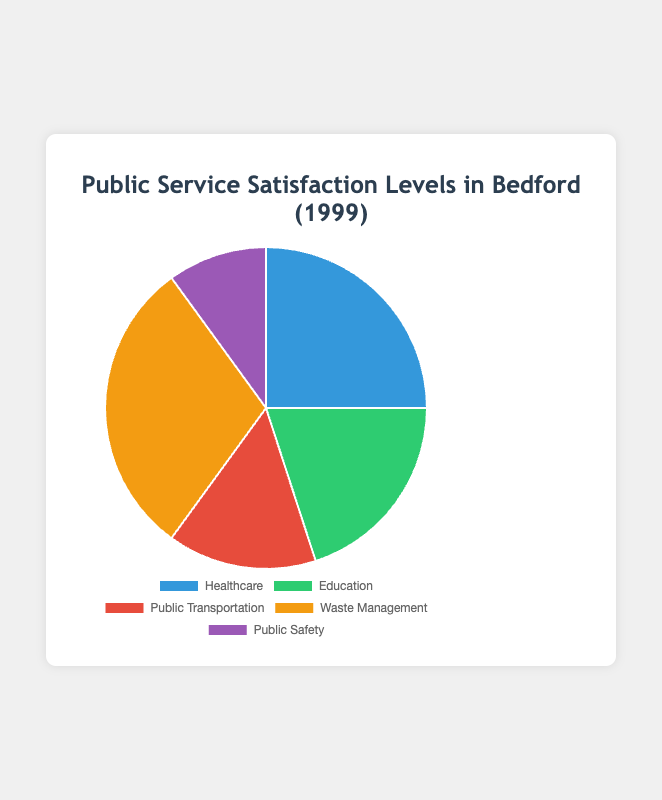Which public service category has the highest satisfaction level? The pie chart shows the percentage distribution of satisfaction levels. The segment with the highest value represents the category with the highest satisfaction level.
Answer: Waste Management Which category accounts for the smallest portion of satisfaction? By examining the pie chart, the smallest segment represents the category with the lowest satisfaction percentage.
Answer: Public Safety What is the total satisfaction percentage for Healthcare and Education combined? Add the satisfaction percentages of Healthcare and Education: 25% (Healthcare) + 20% (Education) = 45%.
Answer: 45% How much lower is the satisfaction level for Public Safety compared to Waste Management? Subtract the satisfaction percentage of Public Safety (10%) from Waste Management (30%): 30% - 10% = 20%.
Answer: 20% If you combined the satisfaction levels of Public Transportation and Public Safety, would it be higher, lower, or equal to Healthcare satisfaction? Add the satisfaction percentages of Public Transportation (15%) and Public Safety (10%) giving a total of 25%. Compare this with the Healthcare satisfaction of 25%.
Answer: Equal What is the ratio of Healthcare satisfaction to Public Safety satisfaction? Divide the Healthcare satisfaction percentage by the Public Safety satisfaction percentage: 25% / 10% = 2.5.
Answer: 2.5 Which category accounts for one-fifth of the total satisfaction? One-fifth of the total satisfaction percentage (100%) is 20%. The category represented by this segment in the pie chart is Education.
Answer: Education What is the average satisfaction percentage of all categories? Add all satisfaction percentages and divide by the number of categories: (25% + 20% + 15% + 30% + 10%) / 5 = 20%.
Answer: 20% Which categories together constitute 50% of the total satisfaction? Look for the categories whose combined satisfaction percentages equal 50%. Public Transportation and Waste Management: 15% + 30% = 45% (not 50%), Healthcare and Education: 25% + 20% = 45% (not 50%). Healthcare, Education, and Public Safety: 25% + 20% + 10% = 55%. Hence, combinations including Public Safety and Healthcare equaled 55%. Combinations including Waste Management (30%) and Public Safety reached 50%.
Answer: Public Safety and Waste Management What is the difference in satisfaction levels between Education and Public Transportation? Subtract the satisfaction percentage of Public Transportation (15%) from Education (20%): 20% - 15% = 5%.
Answer: 5% 